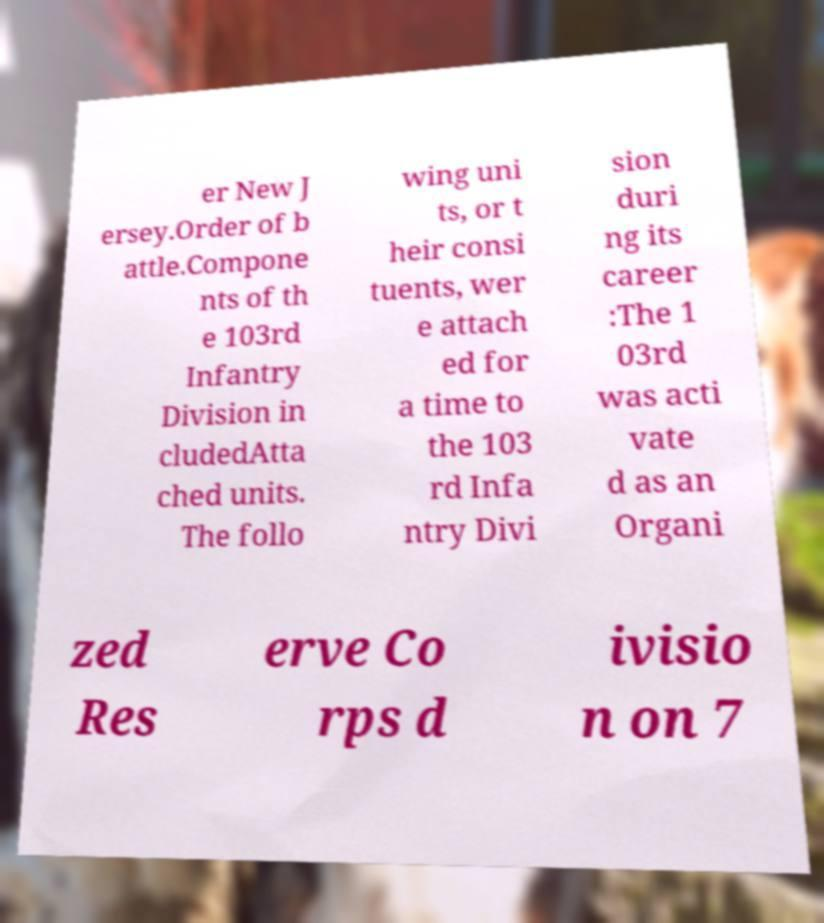What messages or text are displayed in this image? I need them in a readable, typed format. er New J ersey.Order of b attle.Compone nts of th e 103rd Infantry Division in cludedAtta ched units. The follo wing uni ts, or t heir consi tuents, wer e attach ed for a time to the 103 rd Infa ntry Divi sion duri ng its career :The 1 03rd was acti vate d as an Organi zed Res erve Co rps d ivisio n on 7 